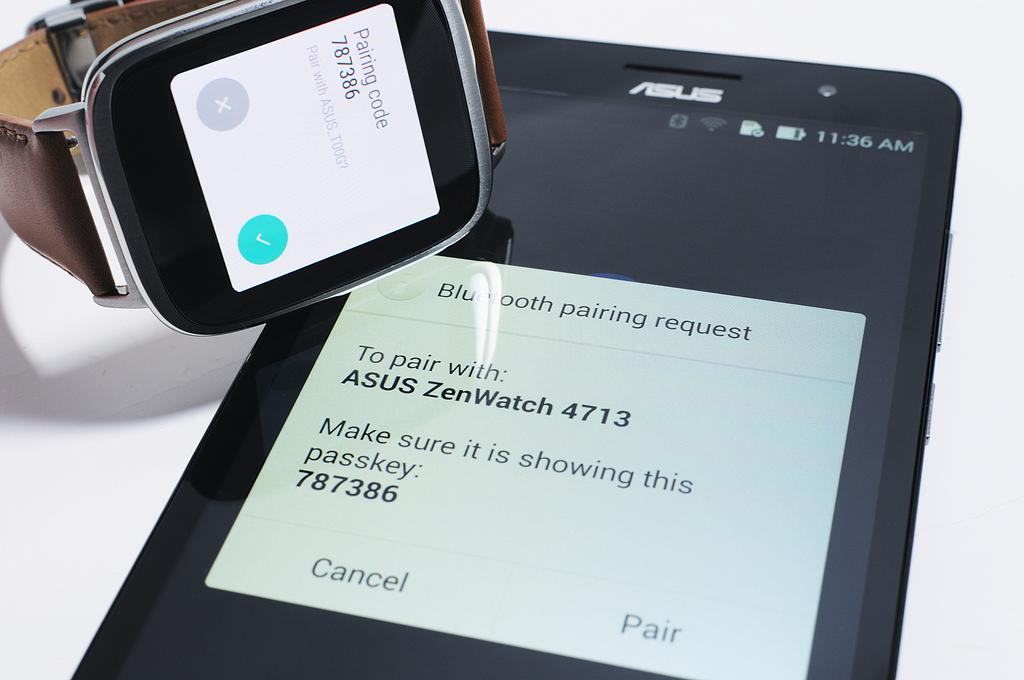What type of object is hanging in the image? There is a mobile in the image. What other object can be seen in the image? There is a watch in the image. How does the mobile care for the twig in the image? There is no twig present in the image, and the mobile does not care for any objects. What role does the brother play in the image? There is no brother present in the image. 